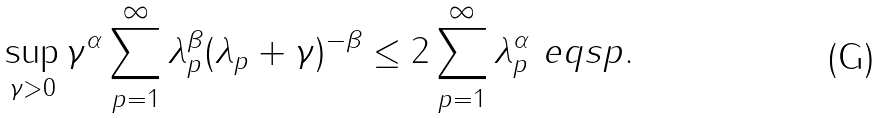Convert formula to latex. <formula><loc_0><loc_0><loc_500><loc_500>\sup _ { \gamma > 0 } \gamma ^ { \alpha } \sum _ { p = 1 } ^ { \infty } \lambda _ { p } ^ { \beta } ( \lambda _ { p } + \gamma ) ^ { - \beta } \leq 2 \sum _ { p = 1 } ^ { \infty } \lambda _ { p } ^ { \alpha } \ e q s p .</formula> 